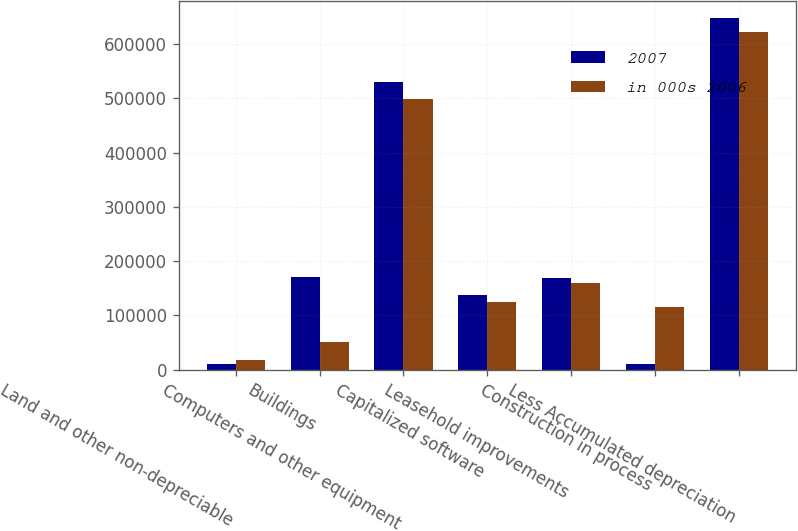Convert chart. <chart><loc_0><loc_0><loc_500><loc_500><stacked_bar_chart><ecel><fcel>Land and other non-depreciable<fcel>Buildings<fcel>Computers and other equipment<fcel>Capitalized software<fcel>Leasehold improvements<fcel>Construction in process<fcel>Less Accumulated depreciation<nl><fcel>2007<fcel>9592<fcel>170904<fcel>530713<fcel>137011<fcel>168370<fcel>9627<fcel>647151<nl><fcel>in 000s 2006<fcel>17152<fcel>50232<fcel>499004<fcel>124065<fcel>159872<fcel>116074<fcel>622693<nl></chart> 